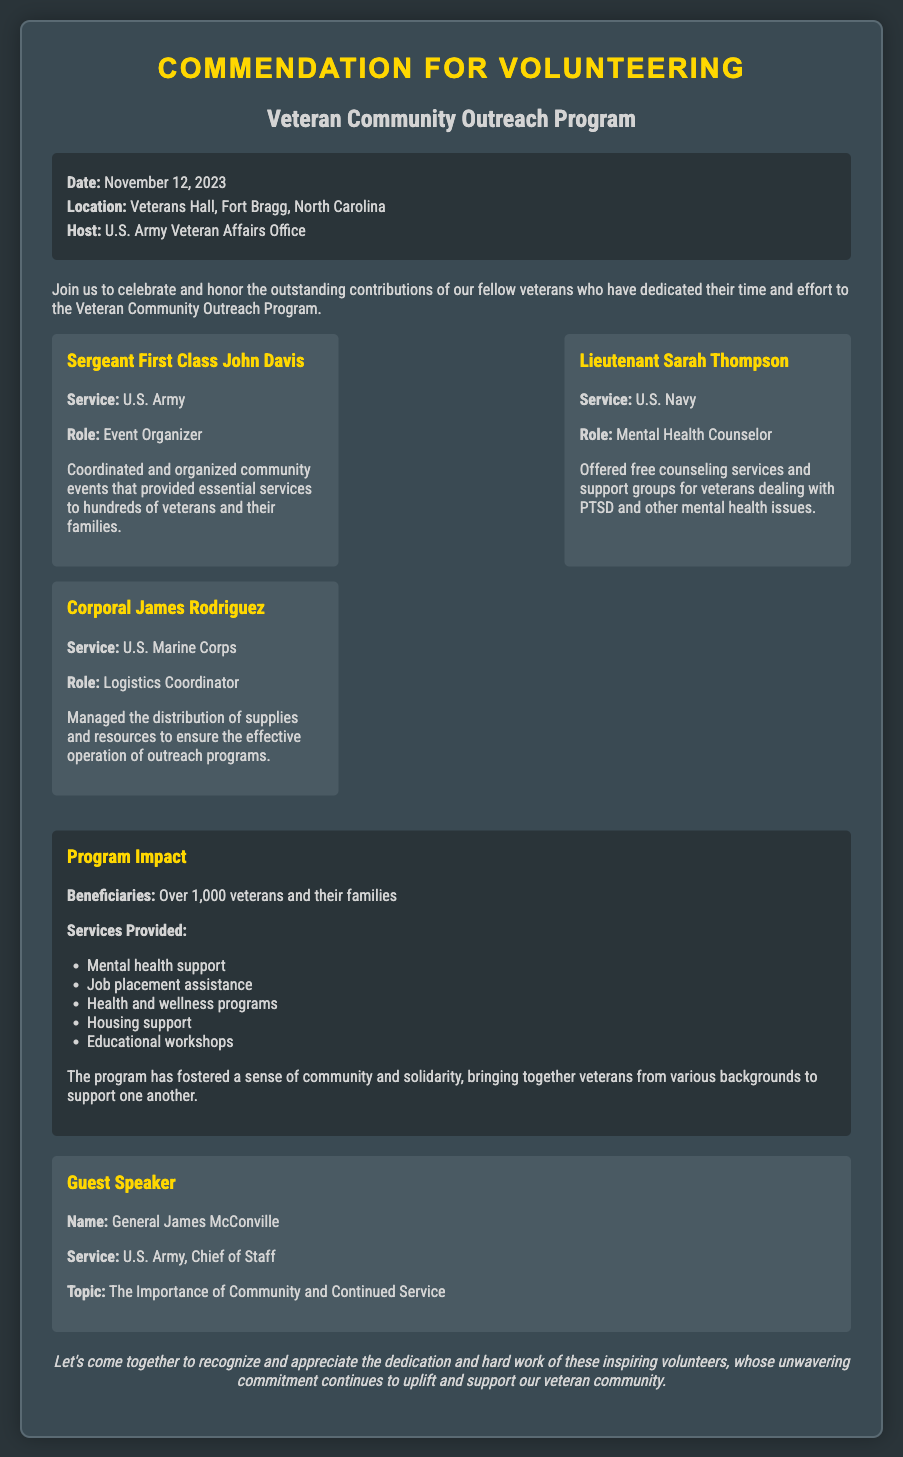What is the date of the event? The date of the event is explicitly mentioned in the document.
Answer: November 12, 2023 Where is the event taking place? The document provides the location of the event in the event details section.
Answer: Veterans Hall, Fort Bragg, North Carolina Who is the host of the program? The document states who is hosting the event under the event details section.
Answer: U.S. Army Veteran Affairs Office What role did Sergeant First Class John Davis have? The role of Sergeant First Class John Davis is specified in the volunteer section.
Answer: Event Organizer How many beneficiaries were served by the program? The number of beneficiaries is indicated in the impact section of the document.
Answer: Over 1,000 veterans and their families What topic will General James McConville speak about? The document lists the topic that General James McConville will cover in the guest speaker section.
Answer: The Importance of Community and Continued Service Which service branch did Lieutenant Sarah Thompson serve? The service branch for Lieutenant Sarah Thompson is noted in her volunteer details.
Answer: U.S. Navy What type of role did Corporal James Rodriguez hold? The document specifies Corporal James Rodriguez's role in the volunteer section.
Answer: Logistics Coordinator What kind of support is provided by the outreach program? The document lists various services offered by the program under the impact section.
Answer: Mental health support, Job placement assistance, Health and wellness programs, Housing support, Educational workshops 